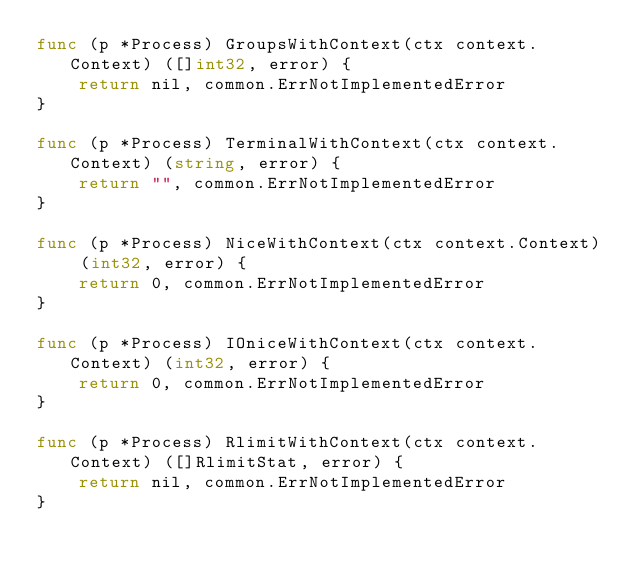<code> <loc_0><loc_0><loc_500><loc_500><_Go_>func (p *Process) GroupsWithContext(ctx context.Context) ([]int32, error) {
	return nil, common.ErrNotImplementedError
}

func (p *Process) TerminalWithContext(ctx context.Context) (string, error) {
	return "", common.ErrNotImplementedError
}

func (p *Process) NiceWithContext(ctx context.Context) (int32, error) {
	return 0, common.ErrNotImplementedError
}

func (p *Process) IOniceWithContext(ctx context.Context) (int32, error) {
	return 0, common.ErrNotImplementedError
}

func (p *Process) RlimitWithContext(ctx context.Context) ([]RlimitStat, error) {
	return nil, common.ErrNotImplementedError
}
</code> 